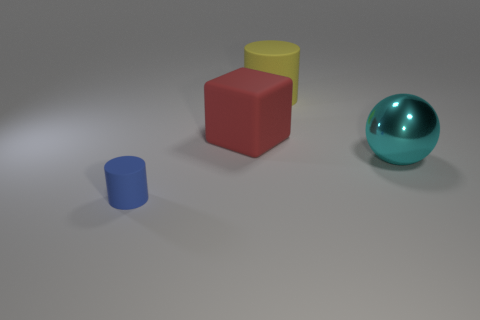How many objects are there, and can you describe each one? There are four objects in the image. Starting from the left, there's a small blue cylinder, a medium-sized red cube, a yellow cylinder slightly larger than the red cube, and a large, shiny cyan-colored sphere on the right. 